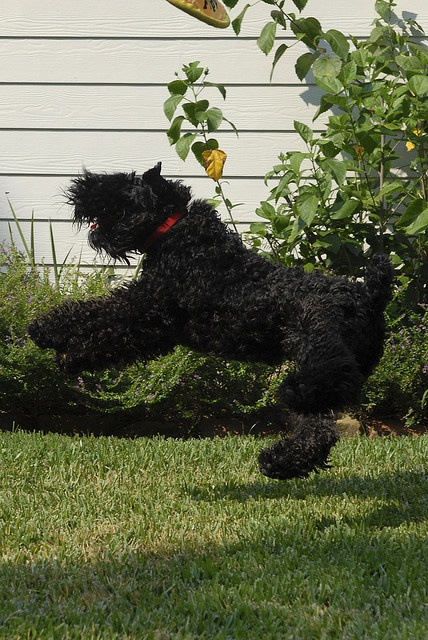Describe the objects in this image and their specific colors. I can see dog in lightgray, black, gray, darkgreen, and maroon tones and frisbee in lightgray and olive tones in this image. 